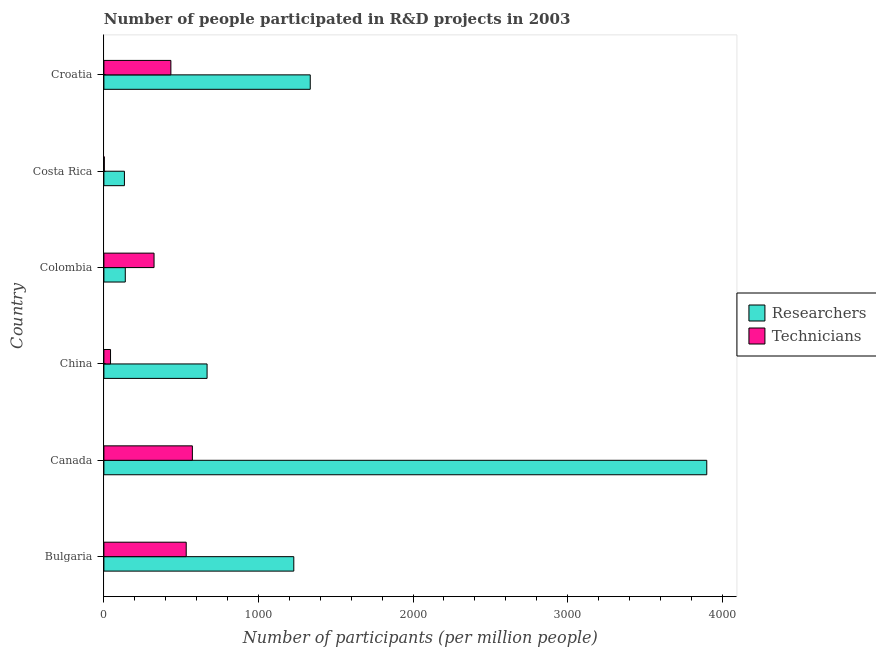Are the number of bars per tick equal to the number of legend labels?
Your answer should be compact. Yes. How many bars are there on the 4th tick from the bottom?
Make the answer very short. 2. In how many cases, is the number of bars for a given country not equal to the number of legend labels?
Your answer should be compact. 0. What is the number of technicians in Croatia?
Provide a succinct answer. 433.35. Across all countries, what is the maximum number of technicians?
Offer a terse response. 572.37. Across all countries, what is the minimum number of researchers?
Keep it short and to the point. 132.82. In which country was the number of technicians minimum?
Offer a terse response. Costa Rica. What is the total number of researchers in the graph?
Ensure brevity in your answer.  7402.36. What is the difference between the number of technicians in China and that in Costa Rica?
Your response must be concise. 40.31. What is the difference between the number of researchers in Bulgaria and the number of technicians in Croatia?
Give a very brief answer. 795.22. What is the average number of researchers per country?
Offer a terse response. 1233.73. What is the difference between the number of researchers and number of technicians in Croatia?
Provide a succinct answer. 901.64. In how many countries, is the number of technicians greater than 2600 ?
Make the answer very short. 0. What is the ratio of the number of researchers in Canada to that in China?
Your response must be concise. 5.84. What is the difference between the highest and the second highest number of technicians?
Offer a very short reply. 39.75. What is the difference between the highest and the lowest number of researchers?
Your answer should be very brief. 3767.29. In how many countries, is the number of researchers greater than the average number of researchers taken over all countries?
Offer a very short reply. 2. Is the sum of the number of technicians in Bulgaria and China greater than the maximum number of researchers across all countries?
Provide a succinct answer. No. What does the 1st bar from the top in Costa Rica represents?
Offer a very short reply. Technicians. What does the 1st bar from the bottom in Bulgaria represents?
Give a very brief answer. Researchers. Are all the bars in the graph horizontal?
Ensure brevity in your answer.  Yes. What is the difference between two consecutive major ticks on the X-axis?
Give a very brief answer. 1000. Are the values on the major ticks of X-axis written in scientific E-notation?
Give a very brief answer. No. Does the graph contain any zero values?
Provide a short and direct response. No. How many legend labels are there?
Your answer should be very brief. 2. What is the title of the graph?
Your answer should be very brief. Number of people participated in R&D projects in 2003. What is the label or title of the X-axis?
Your answer should be very brief. Number of participants (per million people). What is the label or title of the Y-axis?
Your answer should be compact. Country. What is the Number of participants (per million people) of Researchers in Bulgaria?
Make the answer very short. 1228.56. What is the Number of participants (per million people) of Technicians in Bulgaria?
Ensure brevity in your answer.  532.62. What is the Number of participants (per million people) of Researchers in Canada?
Give a very brief answer. 3900.1. What is the Number of participants (per million people) of Technicians in Canada?
Your answer should be very brief. 572.37. What is the Number of participants (per million people) of Researchers in China?
Make the answer very short. 667.53. What is the Number of participants (per million people) of Technicians in China?
Offer a terse response. 42.94. What is the Number of participants (per million people) of Researchers in Colombia?
Your answer should be very brief. 138.35. What is the Number of participants (per million people) of Technicians in Colombia?
Your answer should be compact. 324.45. What is the Number of participants (per million people) of Researchers in Costa Rica?
Keep it short and to the point. 132.82. What is the Number of participants (per million people) of Technicians in Costa Rica?
Ensure brevity in your answer.  2.63. What is the Number of participants (per million people) in Researchers in Croatia?
Your answer should be very brief. 1334.99. What is the Number of participants (per million people) in Technicians in Croatia?
Offer a very short reply. 433.35. Across all countries, what is the maximum Number of participants (per million people) of Researchers?
Offer a terse response. 3900.1. Across all countries, what is the maximum Number of participants (per million people) of Technicians?
Give a very brief answer. 572.37. Across all countries, what is the minimum Number of participants (per million people) of Researchers?
Offer a terse response. 132.82. Across all countries, what is the minimum Number of participants (per million people) in Technicians?
Offer a very short reply. 2.63. What is the total Number of participants (per million people) in Researchers in the graph?
Offer a very short reply. 7402.36. What is the total Number of participants (per million people) in Technicians in the graph?
Your answer should be very brief. 1908.36. What is the difference between the Number of participants (per million people) of Researchers in Bulgaria and that in Canada?
Your answer should be very brief. -2671.54. What is the difference between the Number of participants (per million people) of Technicians in Bulgaria and that in Canada?
Keep it short and to the point. -39.75. What is the difference between the Number of participants (per million people) in Researchers in Bulgaria and that in China?
Make the answer very short. 561.03. What is the difference between the Number of participants (per million people) of Technicians in Bulgaria and that in China?
Offer a terse response. 489.68. What is the difference between the Number of participants (per million people) in Researchers in Bulgaria and that in Colombia?
Make the answer very short. 1090.22. What is the difference between the Number of participants (per million people) in Technicians in Bulgaria and that in Colombia?
Ensure brevity in your answer.  208.17. What is the difference between the Number of participants (per million people) in Researchers in Bulgaria and that in Costa Rica?
Your answer should be compact. 1095.75. What is the difference between the Number of participants (per million people) in Technicians in Bulgaria and that in Costa Rica?
Your answer should be compact. 529.99. What is the difference between the Number of participants (per million people) in Researchers in Bulgaria and that in Croatia?
Your answer should be compact. -106.43. What is the difference between the Number of participants (per million people) in Technicians in Bulgaria and that in Croatia?
Provide a short and direct response. 99.27. What is the difference between the Number of participants (per million people) in Researchers in Canada and that in China?
Your answer should be compact. 3232.57. What is the difference between the Number of participants (per million people) of Technicians in Canada and that in China?
Offer a terse response. 529.43. What is the difference between the Number of participants (per million people) in Researchers in Canada and that in Colombia?
Offer a very short reply. 3761.76. What is the difference between the Number of participants (per million people) of Technicians in Canada and that in Colombia?
Make the answer very short. 247.92. What is the difference between the Number of participants (per million people) of Researchers in Canada and that in Costa Rica?
Give a very brief answer. 3767.29. What is the difference between the Number of participants (per million people) of Technicians in Canada and that in Costa Rica?
Provide a short and direct response. 569.73. What is the difference between the Number of participants (per million people) in Researchers in Canada and that in Croatia?
Provide a succinct answer. 2565.11. What is the difference between the Number of participants (per million people) of Technicians in Canada and that in Croatia?
Your response must be concise. 139.02. What is the difference between the Number of participants (per million people) in Researchers in China and that in Colombia?
Your answer should be compact. 529.19. What is the difference between the Number of participants (per million people) of Technicians in China and that in Colombia?
Provide a short and direct response. -281.51. What is the difference between the Number of participants (per million people) of Researchers in China and that in Costa Rica?
Your response must be concise. 534.71. What is the difference between the Number of participants (per million people) in Technicians in China and that in Costa Rica?
Your response must be concise. 40.31. What is the difference between the Number of participants (per million people) of Researchers in China and that in Croatia?
Your answer should be compact. -667.46. What is the difference between the Number of participants (per million people) in Technicians in China and that in Croatia?
Ensure brevity in your answer.  -390.41. What is the difference between the Number of participants (per million people) in Researchers in Colombia and that in Costa Rica?
Provide a short and direct response. 5.53. What is the difference between the Number of participants (per million people) in Technicians in Colombia and that in Costa Rica?
Ensure brevity in your answer.  321.82. What is the difference between the Number of participants (per million people) of Researchers in Colombia and that in Croatia?
Give a very brief answer. -1196.64. What is the difference between the Number of participants (per million people) in Technicians in Colombia and that in Croatia?
Make the answer very short. -108.9. What is the difference between the Number of participants (per million people) of Researchers in Costa Rica and that in Croatia?
Give a very brief answer. -1202.17. What is the difference between the Number of participants (per million people) in Technicians in Costa Rica and that in Croatia?
Provide a short and direct response. -430.72. What is the difference between the Number of participants (per million people) in Researchers in Bulgaria and the Number of participants (per million people) in Technicians in Canada?
Provide a short and direct response. 656.2. What is the difference between the Number of participants (per million people) in Researchers in Bulgaria and the Number of participants (per million people) in Technicians in China?
Provide a short and direct response. 1185.63. What is the difference between the Number of participants (per million people) of Researchers in Bulgaria and the Number of participants (per million people) of Technicians in Colombia?
Make the answer very short. 904.11. What is the difference between the Number of participants (per million people) of Researchers in Bulgaria and the Number of participants (per million people) of Technicians in Costa Rica?
Your answer should be very brief. 1225.93. What is the difference between the Number of participants (per million people) in Researchers in Bulgaria and the Number of participants (per million people) in Technicians in Croatia?
Provide a succinct answer. 795.22. What is the difference between the Number of participants (per million people) in Researchers in Canada and the Number of participants (per million people) in Technicians in China?
Your answer should be very brief. 3857.16. What is the difference between the Number of participants (per million people) in Researchers in Canada and the Number of participants (per million people) in Technicians in Colombia?
Provide a succinct answer. 3575.65. What is the difference between the Number of participants (per million people) in Researchers in Canada and the Number of participants (per million people) in Technicians in Costa Rica?
Your response must be concise. 3897.47. What is the difference between the Number of participants (per million people) of Researchers in Canada and the Number of participants (per million people) of Technicians in Croatia?
Your answer should be compact. 3466.76. What is the difference between the Number of participants (per million people) in Researchers in China and the Number of participants (per million people) in Technicians in Colombia?
Ensure brevity in your answer.  343.08. What is the difference between the Number of participants (per million people) of Researchers in China and the Number of participants (per million people) of Technicians in Costa Rica?
Ensure brevity in your answer.  664.9. What is the difference between the Number of participants (per million people) of Researchers in China and the Number of participants (per million people) of Technicians in Croatia?
Provide a short and direct response. 234.18. What is the difference between the Number of participants (per million people) of Researchers in Colombia and the Number of participants (per million people) of Technicians in Costa Rica?
Offer a very short reply. 135.71. What is the difference between the Number of participants (per million people) in Researchers in Colombia and the Number of participants (per million people) in Technicians in Croatia?
Provide a short and direct response. -295. What is the difference between the Number of participants (per million people) in Researchers in Costa Rica and the Number of participants (per million people) in Technicians in Croatia?
Offer a terse response. -300.53. What is the average Number of participants (per million people) of Researchers per country?
Your answer should be very brief. 1233.73. What is the average Number of participants (per million people) in Technicians per country?
Keep it short and to the point. 318.06. What is the difference between the Number of participants (per million people) of Researchers and Number of participants (per million people) of Technicians in Bulgaria?
Provide a short and direct response. 695.95. What is the difference between the Number of participants (per million people) of Researchers and Number of participants (per million people) of Technicians in Canada?
Your response must be concise. 3327.74. What is the difference between the Number of participants (per million people) in Researchers and Number of participants (per million people) in Technicians in China?
Make the answer very short. 624.59. What is the difference between the Number of participants (per million people) in Researchers and Number of participants (per million people) in Technicians in Colombia?
Provide a succinct answer. -186.1. What is the difference between the Number of participants (per million people) in Researchers and Number of participants (per million people) in Technicians in Costa Rica?
Keep it short and to the point. 130.18. What is the difference between the Number of participants (per million people) of Researchers and Number of participants (per million people) of Technicians in Croatia?
Make the answer very short. 901.64. What is the ratio of the Number of participants (per million people) of Researchers in Bulgaria to that in Canada?
Provide a succinct answer. 0.32. What is the ratio of the Number of participants (per million people) of Technicians in Bulgaria to that in Canada?
Make the answer very short. 0.93. What is the ratio of the Number of participants (per million people) of Researchers in Bulgaria to that in China?
Ensure brevity in your answer.  1.84. What is the ratio of the Number of participants (per million people) in Technicians in Bulgaria to that in China?
Provide a succinct answer. 12.4. What is the ratio of the Number of participants (per million people) of Researchers in Bulgaria to that in Colombia?
Keep it short and to the point. 8.88. What is the ratio of the Number of participants (per million people) in Technicians in Bulgaria to that in Colombia?
Your response must be concise. 1.64. What is the ratio of the Number of participants (per million people) of Researchers in Bulgaria to that in Costa Rica?
Provide a succinct answer. 9.25. What is the ratio of the Number of participants (per million people) of Technicians in Bulgaria to that in Costa Rica?
Your answer should be compact. 202.27. What is the ratio of the Number of participants (per million people) of Researchers in Bulgaria to that in Croatia?
Your answer should be very brief. 0.92. What is the ratio of the Number of participants (per million people) in Technicians in Bulgaria to that in Croatia?
Make the answer very short. 1.23. What is the ratio of the Number of participants (per million people) in Researchers in Canada to that in China?
Keep it short and to the point. 5.84. What is the ratio of the Number of participants (per million people) in Technicians in Canada to that in China?
Provide a short and direct response. 13.33. What is the ratio of the Number of participants (per million people) in Researchers in Canada to that in Colombia?
Your answer should be compact. 28.19. What is the ratio of the Number of participants (per million people) of Technicians in Canada to that in Colombia?
Provide a short and direct response. 1.76. What is the ratio of the Number of participants (per million people) of Researchers in Canada to that in Costa Rica?
Keep it short and to the point. 29.36. What is the ratio of the Number of participants (per million people) of Technicians in Canada to that in Costa Rica?
Ensure brevity in your answer.  217.36. What is the ratio of the Number of participants (per million people) in Researchers in Canada to that in Croatia?
Your answer should be compact. 2.92. What is the ratio of the Number of participants (per million people) in Technicians in Canada to that in Croatia?
Your response must be concise. 1.32. What is the ratio of the Number of participants (per million people) of Researchers in China to that in Colombia?
Your answer should be compact. 4.83. What is the ratio of the Number of participants (per million people) of Technicians in China to that in Colombia?
Your response must be concise. 0.13. What is the ratio of the Number of participants (per million people) of Researchers in China to that in Costa Rica?
Keep it short and to the point. 5.03. What is the ratio of the Number of participants (per million people) in Technicians in China to that in Costa Rica?
Provide a succinct answer. 16.31. What is the ratio of the Number of participants (per million people) of Researchers in China to that in Croatia?
Keep it short and to the point. 0.5. What is the ratio of the Number of participants (per million people) in Technicians in China to that in Croatia?
Ensure brevity in your answer.  0.1. What is the ratio of the Number of participants (per million people) of Researchers in Colombia to that in Costa Rica?
Your answer should be compact. 1.04. What is the ratio of the Number of participants (per million people) of Technicians in Colombia to that in Costa Rica?
Your response must be concise. 123.21. What is the ratio of the Number of participants (per million people) in Researchers in Colombia to that in Croatia?
Provide a short and direct response. 0.1. What is the ratio of the Number of participants (per million people) of Technicians in Colombia to that in Croatia?
Provide a short and direct response. 0.75. What is the ratio of the Number of participants (per million people) of Researchers in Costa Rica to that in Croatia?
Your response must be concise. 0.1. What is the ratio of the Number of participants (per million people) in Technicians in Costa Rica to that in Croatia?
Offer a very short reply. 0.01. What is the difference between the highest and the second highest Number of participants (per million people) of Researchers?
Ensure brevity in your answer.  2565.11. What is the difference between the highest and the second highest Number of participants (per million people) in Technicians?
Your response must be concise. 39.75. What is the difference between the highest and the lowest Number of participants (per million people) of Researchers?
Keep it short and to the point. 3767.29. What is the difference between the highest and the lowest Number of participants (per million people) of Technicians?
Your response must be concise. 569.73. 